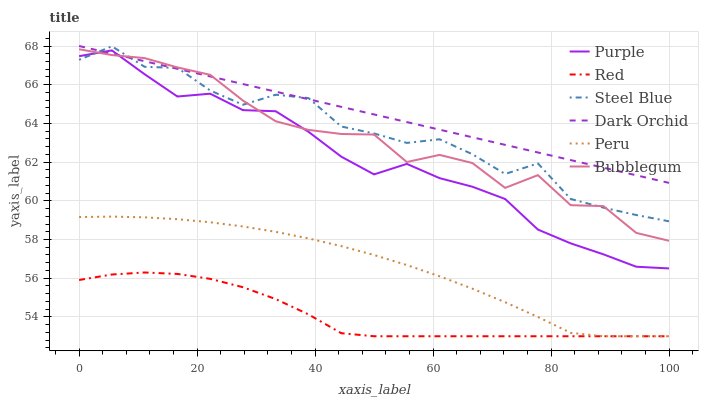Does Red have the minimum area under the curve?
Answer yes or no. Yes. Does Dark Orchid have the maximum area under the curve?
Answer yes or no. Yes. Does Steel Blue have the minimum area under the curve?
Answer yes or no. No. Does Steel Blue have the maximum area under the curve?
Answer yes or no. No. Is Dark Orchid the smoothest?
Answer yes or no. Yes. Is Steel Blue the roughest?
Answer yes or no. Yes. Is Steel Blue the smoothest?
Answer yes or no. No. Is Dark Orchid the roughest?
Answer yes or no. No. Does Peru have the lowest value?
Answer yes or no. Yes. Does Steel Blue have the lowest value?
Answer yes or no. No. Does Dark Orchid have the highest value?
Answer yes or no. Yes. Does Steel Blue have the highest value?
Answer yes or no. No. Is Red less than Dark Orchid?
Answer yes or no. Yes. Is Purple greater than Peru?
Answer yes or no. Yes. Does Purple intersect Dark Orchid?
Answer yes or no. Yes. Is Purple less than Dark Orchid?
Answer yes or no. No. Is Purple greater than Dark Orchid?
Answer yes or no. No. Does Red intersect Dark Orchid?
Answer yes or no. No. 